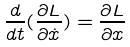<formula> <loc_0><loc_0><loc_500><loc_500>\frac { d } { d t } ( \frac { \partial L } { \partial \dot { x } } ) = \frac { \partial L } { \partial x }</formula> 